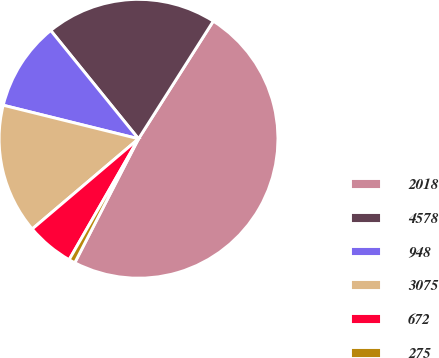<chart> <loc_0><loc_0><loc_500><loc_500><pie_chart><fcel>2018<fcel>4578<fcel>948<fcel>3075<fcel>672<fcel>275<nl><fcel>48.55%<fcel>19.85%<fcel>10.29%<fcel>15.07%<fcel>5.51%<fcel>0.73%<nl></chart> 